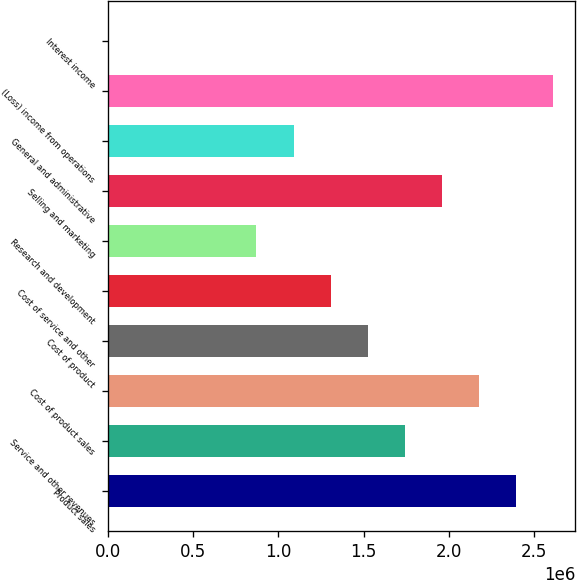Convert chart to OTSL. <chart><loc_0><loc_0><loc_500><loc_500><bar_chart><fcel>Product sales<fcel>Service and other revenues<fcel>Cost of product sales<fcel>Cost of product<fcel>Cost of service and other<fcel>Research and development<fcel>Selling and marketing<fcel>General and administrative<fcel>(Loss) income from operations<fcel>Interest income<nl><fcel>2.39374e+06<fcel>1.74122e+06<fcel>2.17624e+06<fcel>1.52371e+06<fcel>1.30621e+06<fcel>871191<fcel>1.95873e+06<fcel>1.0887e+06<fcel>2.61125e+06<fcel>1161<nl></chart> 